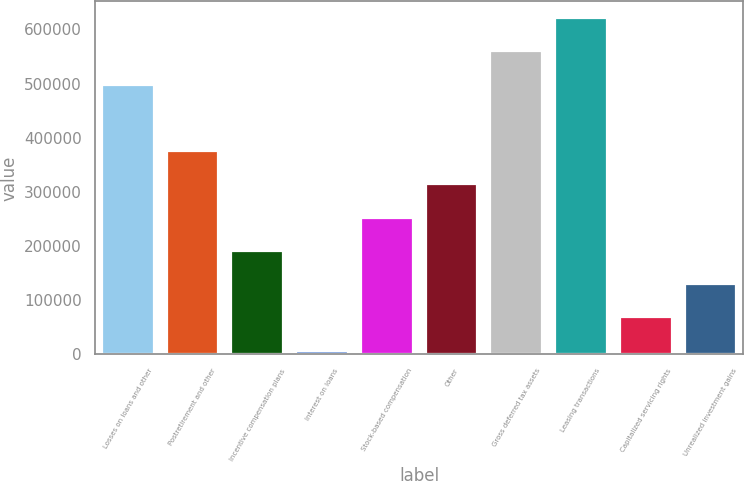<chart> <loc_0><loc_0><loc_500><loc_500><bar_chart><fcel>Losses on loans and other<fcel>Postretirement and other<fcel>Incentive compensation plans<fcel>Interest on loans<fcel>Stock-based compensation<fcel>Other<fcel>Gross deferred tax assets<fcel>Leasing transactions<fcel>Capitalized servicing rights<fcel>Unrealized investment gains<nl><fcel>498039<fcel>375302<fcel>191196<fcel>7091<fcel>252565<fcel>313934<fcel>559408<fcel>620776<fcel>68459.5<fcel>129828<nl></chart> 